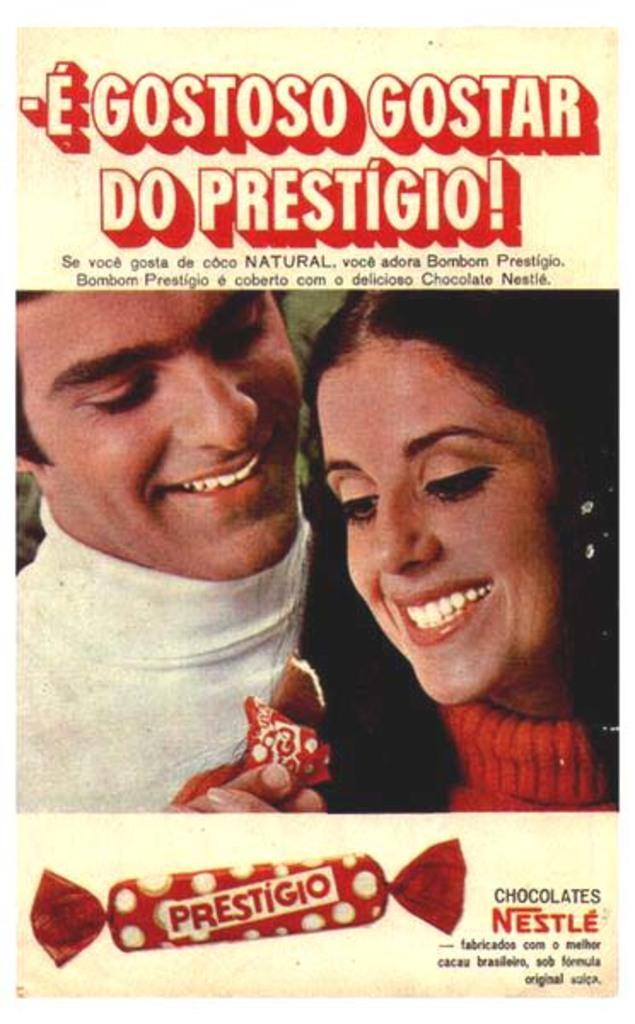What is present in the image? There is a poster in the image. What can be found on the poster? The poster contains pictures and text. Where is the brother mentioned in the image? There is no mention of a brother in the image; it only features a poster with pictures and text. 